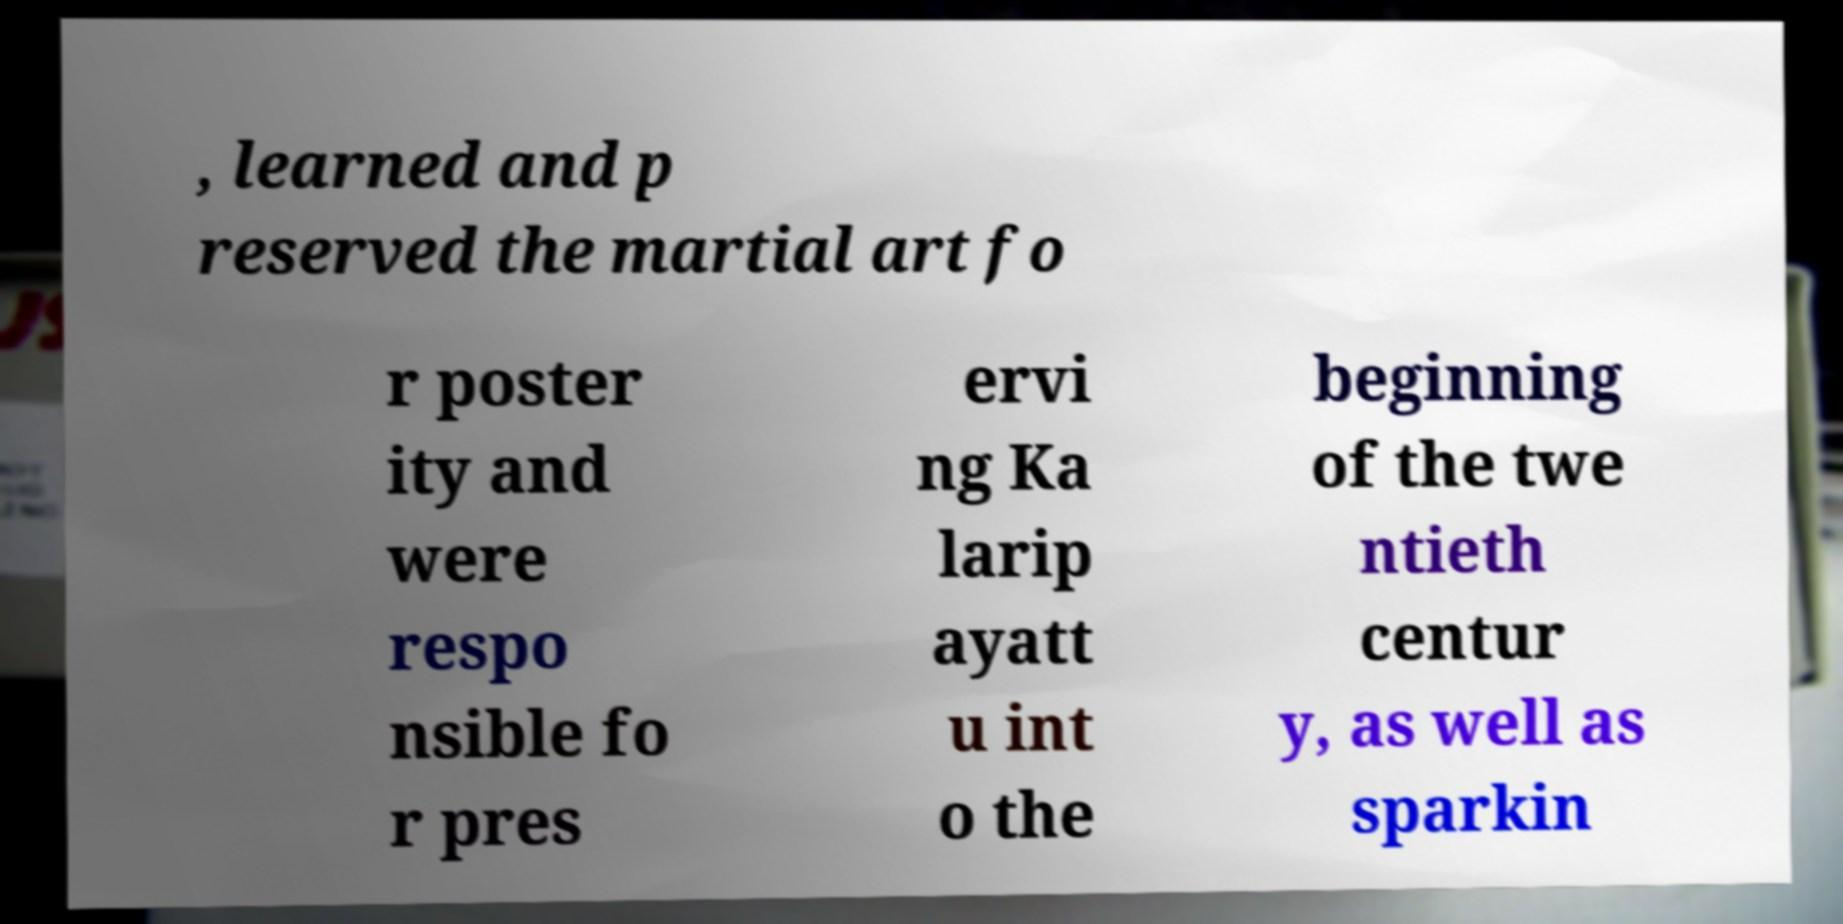I need the written content from this picture converted into text. Can you do that? , learned and p reserved the martial art fo r poster ity and were respo nsible fo r pres ervi ng Ka larip ayatt u int o the beginning of the twe ntieth centur y, as well as sparkin 